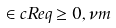<formula> <loc_0><loc_0><loc_500><loc_500>\in c R e q \geq 0 , \nu m</formula> 